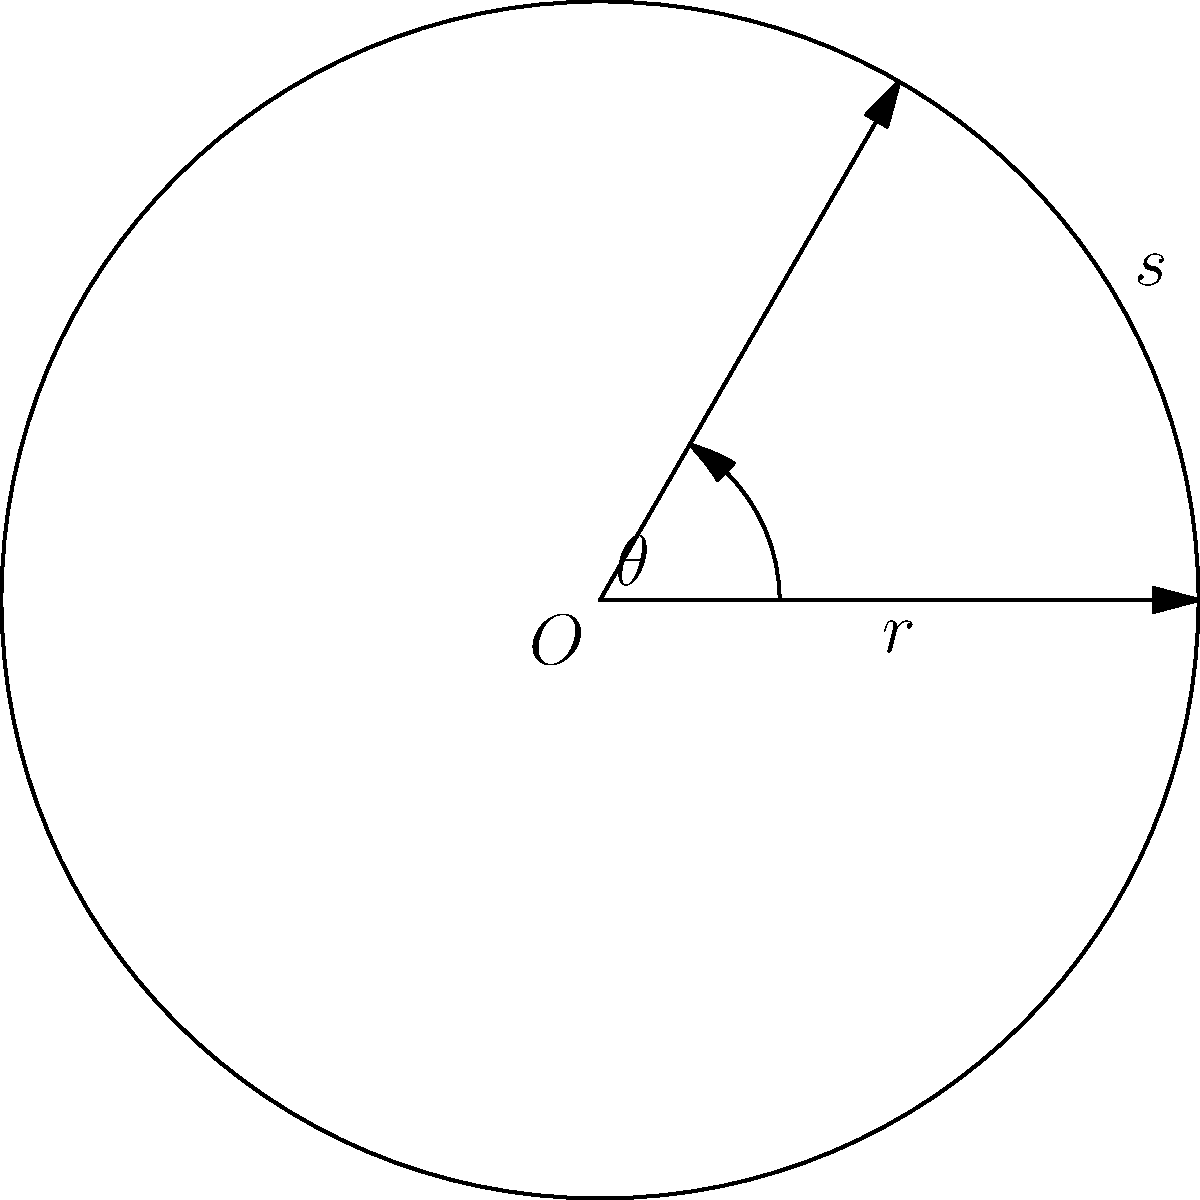As a budget airline executive, you're reviewing a new flight path that requires a tight turn. The plane's turning radius is 3 km, and the arc length of the turn is 2.5 km. Calculate the central angle $\theta$ (in degrees) of the circular sector representing this turn. How does this compare to your airline's standard 30° banking angle for passenger comfort? Let's approach this step-by-step:

1) We know that for a circular sector:
   $s = r\theta$, where
   $s$ is the arc length,
   $r$ is the radius, and
   $\theta$ is the central angle in radians.

2) We're given:
   $r = 3$ km
   $s = 2.5$ km

3) Substituting these into the formula:
   $2.5 = 3\theta$

4) Solving for $\theta$:
   $\theta = \frac{2.5}{3} \approx 0.8333$ radians

5) To convert radians to degrees, we multiply by $\frac{180}{\pi}$:
   $\theta = 0.8333 \times \frac{180}{\pi} \approx 47.75°$

6) Comparing to the standard 30° banking angle:
   $47.75° - 30° = 17.75°$

This turn is 17.75° sharper than the standard banking angle, which might affect passenger comfort but could lead to more efficient routes and fuel savings.
Answer: $47.75°$, exceeding standard by $17.75°$ 